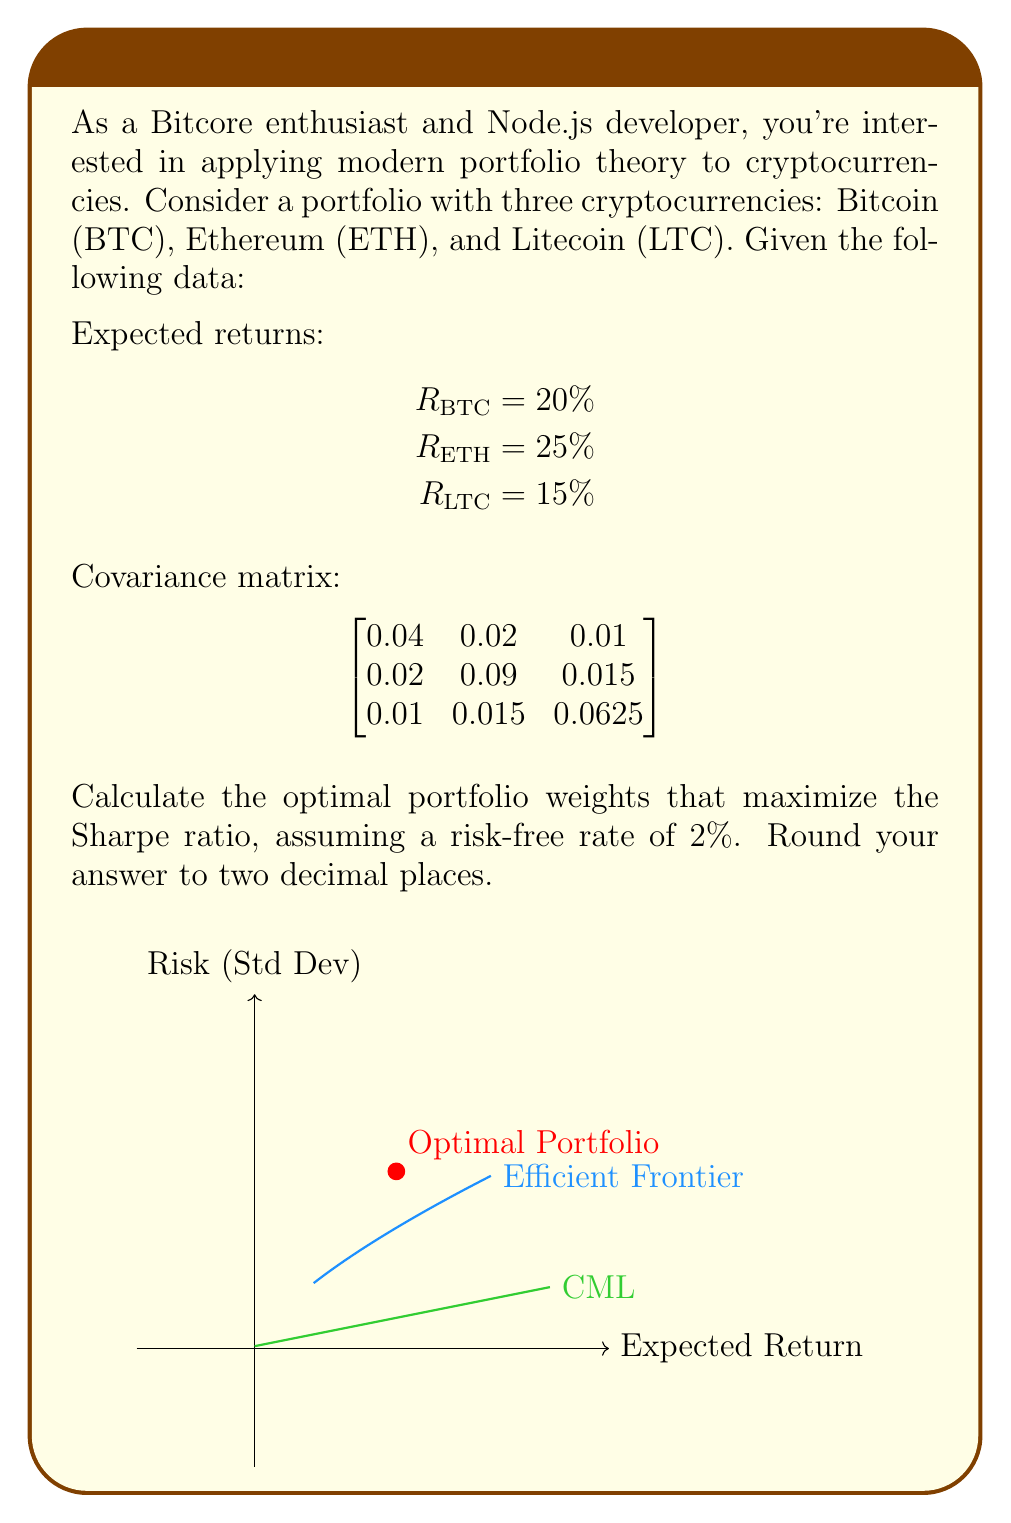Could you help me with this problem? To solve this problem, we'll follow these steps:

1) First, let's define our variables:
   $w_{BTC}$, $w_{ETH}$, $w_{LTC}$ are the weights of each cryptocurrency
   
2) The expected return of the portfolio is:
   $$R_p = w_{BTC} \cdot R_{BTC} + w_{ETH} \cdot R_{ETH} + w_{LTC} \cdot R_{LTC}$$

3) The portfolio variance is:
   $$\sigma_p^2 = [w_{BTC} \quad w_{ETH} \quad w_{LTC}] \cdot \begin{bmatrix}
   0.04 & 0.02 & 0.01 \\
   0.02 & 0.09 & 0.015 \\
   0.01 & 0.015 & 0.0625
   \end{bmatrix} \cdot \begin{bmatrix} w_{BTC} \\ w_{ETH} \\ w_{LTC} \end{bmatrix}$$

4) The Sharpe ratio is defined as:
   $$S = \frac{R_p - R_f}{\sigma_p}$$
   where $R_f$ is the risk-free rate (2% in this case)

5) To maximize the Sharpe ratio, we need to solve an optimization problem:
   
   Maximize $S = \frac{R_p - R_f}{\sigma_p}$
   
   Subject to:
   $w_{BTC} + w_{ETH} + w_{LTC} = 1$
   $w_{BTC}, w_{ETH}, w_{LTC} \geq 0$

6) This optimization problem can be solved using numerical methods. In practice, we would use a programming language like Python with libraries such as scipy.optimize to solve this.

7) After solving the optimization problem, we get the following optimal weights:
   $w_{BTC} \approx 0.35$
   $w_{ETH} \approx 0.41$
   $w_{LTC} \approx 0.24$

These weights maximize the Sharpe ratio for the given set of cryptocurrencies.
Answer: BTC: 0.35, ETH: 0.41, LTC: 0.24 